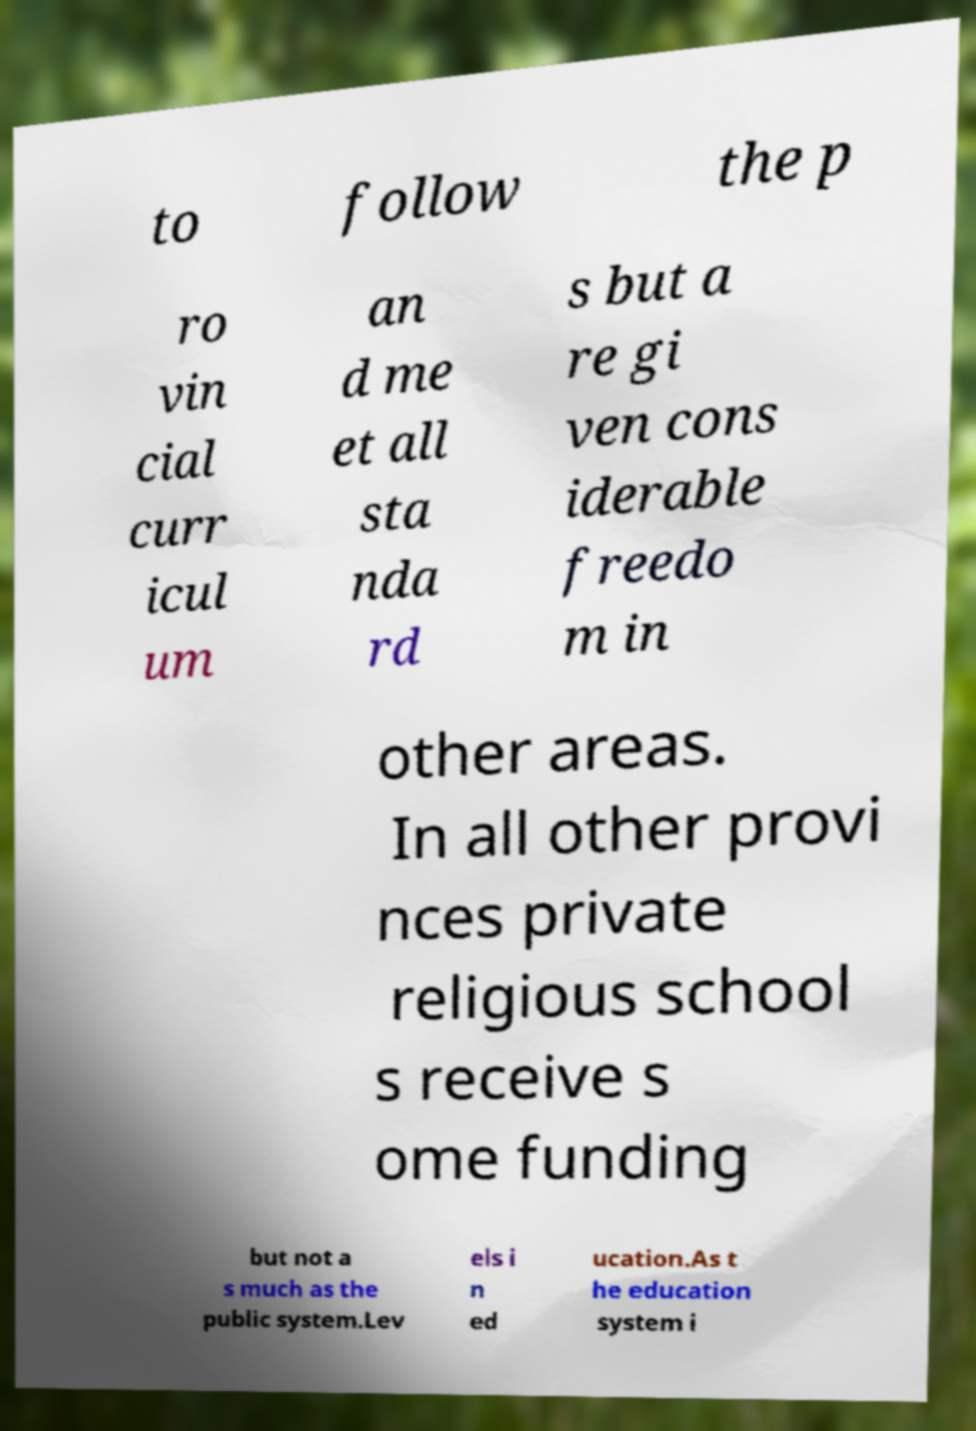Can you read and provide the text displayed in the image?This photo seems to have some interesting text. Can you extract and type it out for me? to follow the p ro vin cial curr icul um an d me et all sta nda rd s but a re gi ven cons iderable freedo m in other areas. In all other provi nces private religious school s receive s ome funding but not a s much as the public system.Lev els i n ed ucation.As t he education system i 